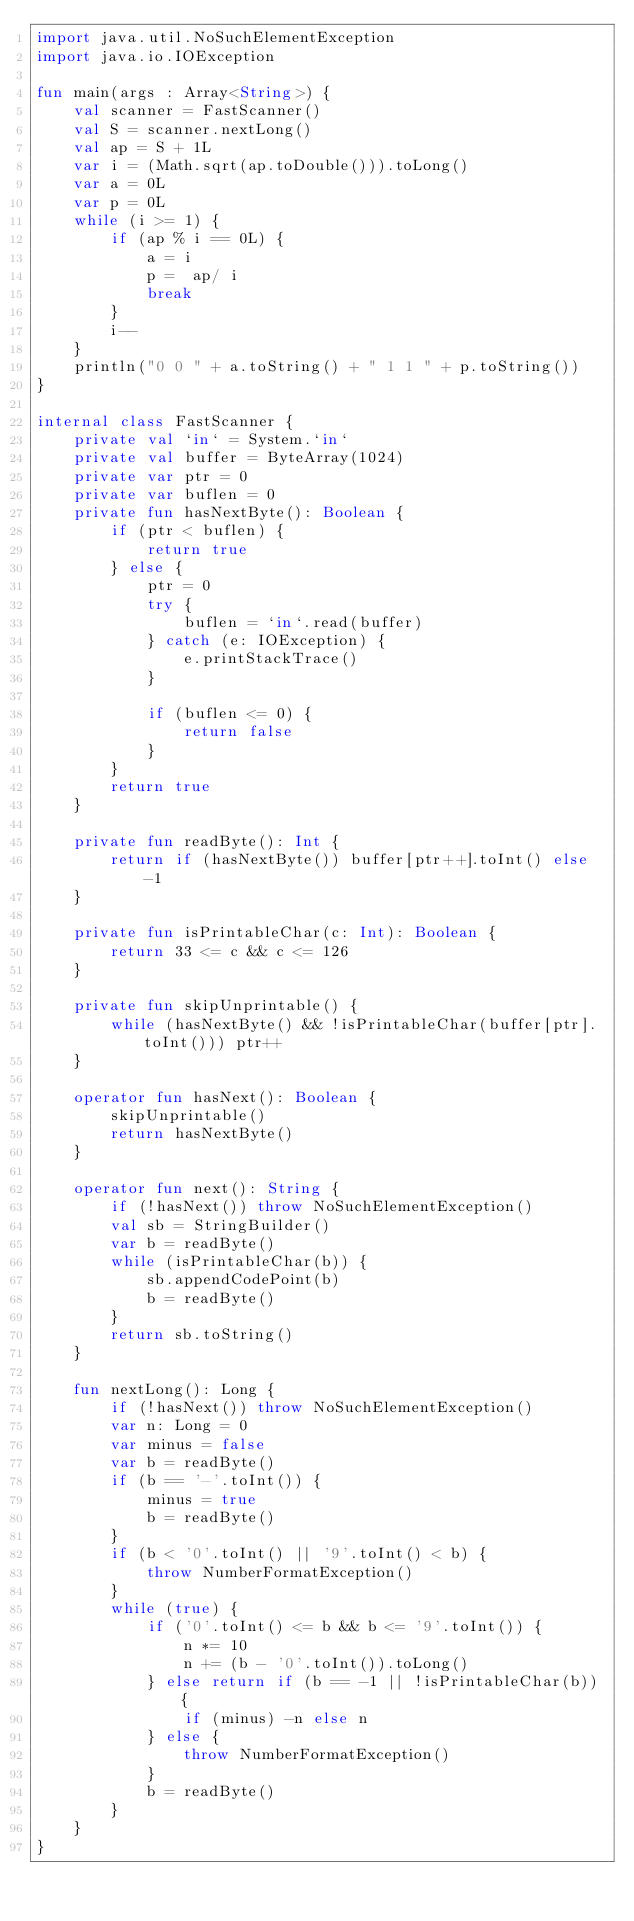Convert code to text. <code><loc_0><loc_0><loc_500><loc_500><_Kotlin_>import java.util.NoSuchElementException
import java.io.IOException

fun main(args : Array<String>) {
    val scanner = FastScanner()
    val S = scanner.nextLong()
    val ap = S + 1L
    var i = (Math.sqrt(ap.toDouble())).toLong()
    var a = 0L
    var p = 0L
    while (i >= 1) {
        if (ap % i == 0L) {
            a = i
            p =  ap/ i
            break
        }
        i--
    }
    println("0 0 " + a.toString() + " 1 1 " + p.toString())
}

internal class FastScanner {
    private val `in` = System.`in`
    private val buffer = ByteArray(1024)
    private var ptr = 0
    private var buflen = 0
    private fun hasNextByte(): Boolean {
        if (ptr < buflen) {
            return true
        } else {
            ptr = 0
            try {
                buflen = `in`.read(buffer)
            } catch (e: IOException) {
                e.printStackTrace()
            }

            if (buflen <= 0) {
                return false
            }
        }
        return true
    }

    private fun readByte(): Int {
        return if (hasNextByte()) buffer[ptr++].toInt() else -1
    }

    private fun isPrintableChar(c: Int): Boolean {
        return 33 <= c && c <= 126
    }

    private fun skipUnprintable() {
        while (hasNextByte() && !isPrintableChar(buffer[ptr].toInt())) ptr++
    }

    operator fun hasNext(): Boolean {
        skipUnprintable()
        return hasNextByte()
    }

    operator fun next(): String {
        if (!hasNext()) throw NoSuchElementException()
        val sb = StringBuilder()
        var b = readByte()
        while (isPrintableChar(b)) {
            sb.appendCodePoint(b)
            b = readByte()
        }
        return sb.toString()
    }

    fun nextLong(): Long {
        if (!hasNext()) throw NoSuchElementException()
        var n: Long = 0
        var minus = false
        var b = readByte()
        if (b == '-'.toInt()) {
            minus = true
            b = readByte()
        }
        if (b < '0'.toInt() || '9'.toInt() < b) {
            throw NumberFormatException()
        }
        while (true) {
            if ('0'.toInt() <= b && b <= '9'.toInt()) {
                n *= 10
                n += (b - '0'.toInt()).toLong()
            } else return if (b == -1 || !isPrintableChar(b)) {
                if (minus) -n else n
            } else {
                throw NumberFormatException()
            }
            b = readByte()
        }
    }
}</code> 